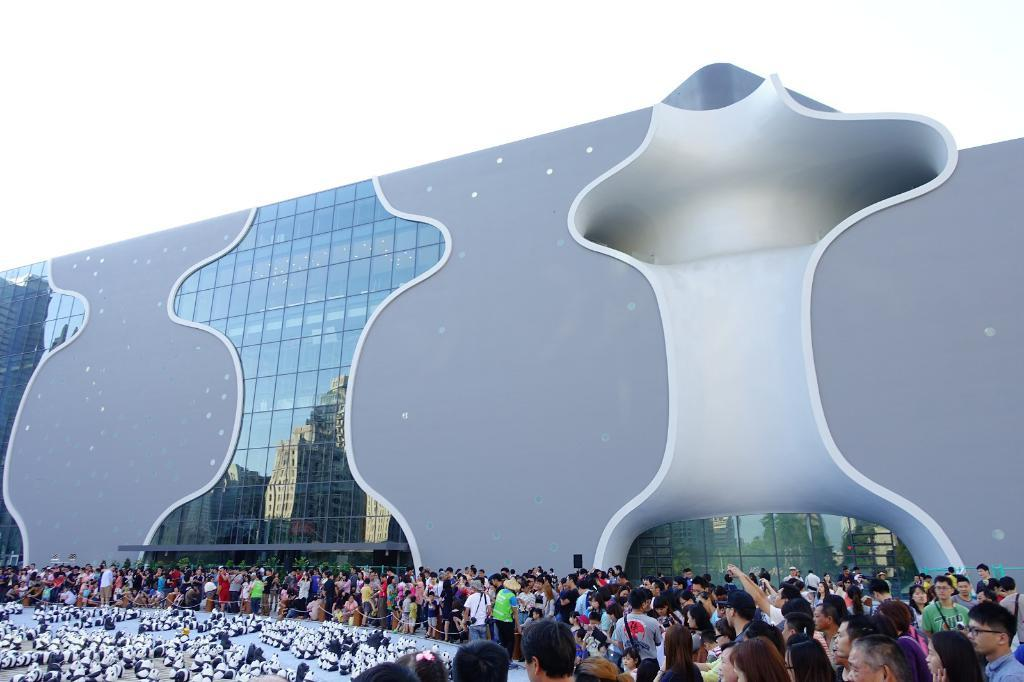What are the people in the image doing? The persons standing on the floor in the image are likely interacting with the toy pandas. What objects are present in the image that might be used for safety or organization? Barrier poles are present in the image. What type of natural elements can be seen in the image? There are trees in the image. What type of man-made structure is visible in the image? There is a building in the image. What is visible in the background of the image? The sky is visible in the image. What type of slave is depicted in the image? There is no depiction of a slave in the image; it features persons interacting with toy pandas. What type of coat is being worn by the crook in the image? There is no crook or coat present in the image. 